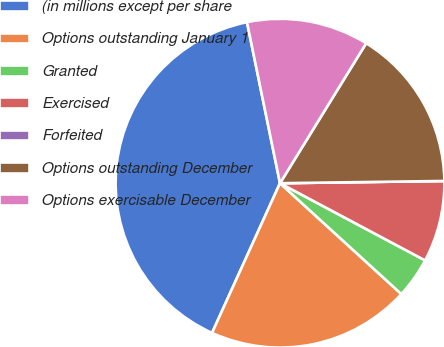Convert chart. <chart><loc_0><loc_0><loc_500><loc_500><pie_chart><fcel>(in millions except per share<fcel>Options outstanding January 1<fcel>Granted<fcel>Exercised<fcel>Forfeited<fcel>Options outstanding December<fcel>Options exercisable December<nl><fcel>40.0%<fcel>20.0%<fcel>4.0%<fcel>8.0%<fcel>0.0%<fcel>16.0%<fcel>12.0%<nl></chart> 